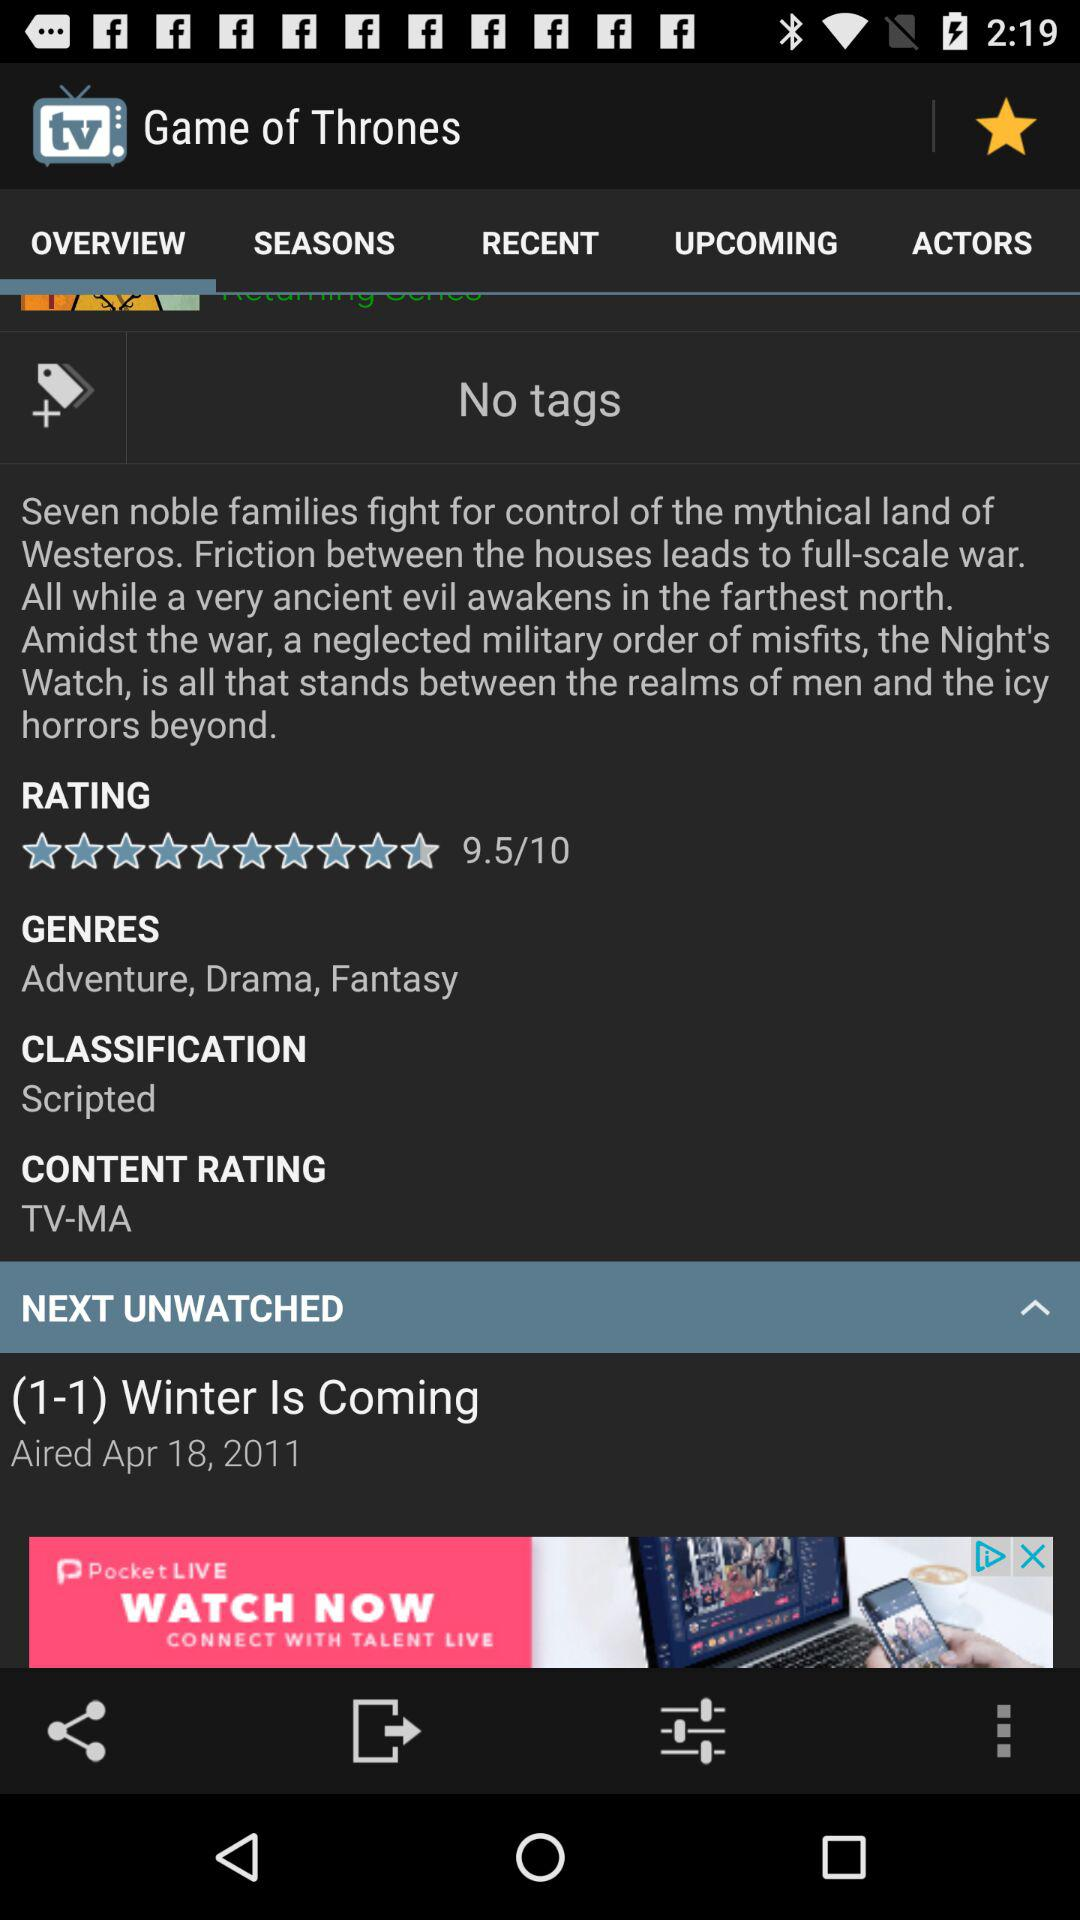What are the genres? The genres are adventure, drama and fantasy. 